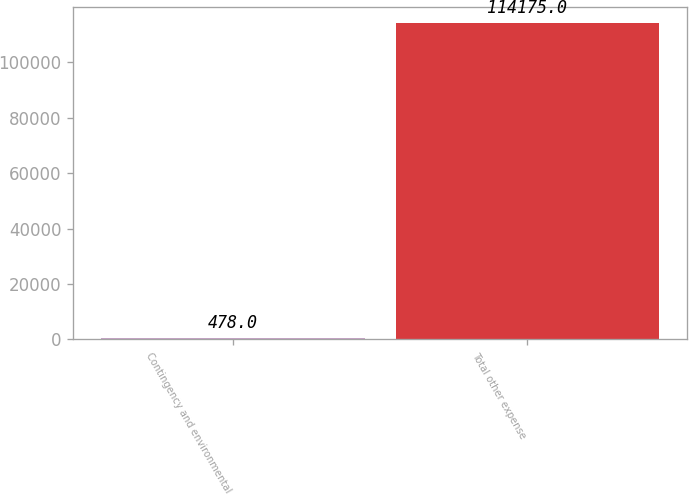Convert chart. <chart><loc_0><loc_0><loc_500><loc_500><bar_chart><fcel>Contingency and environmental<fcel>Total other expense<nl><fcel>478<fcel>114175<nl></chart> 